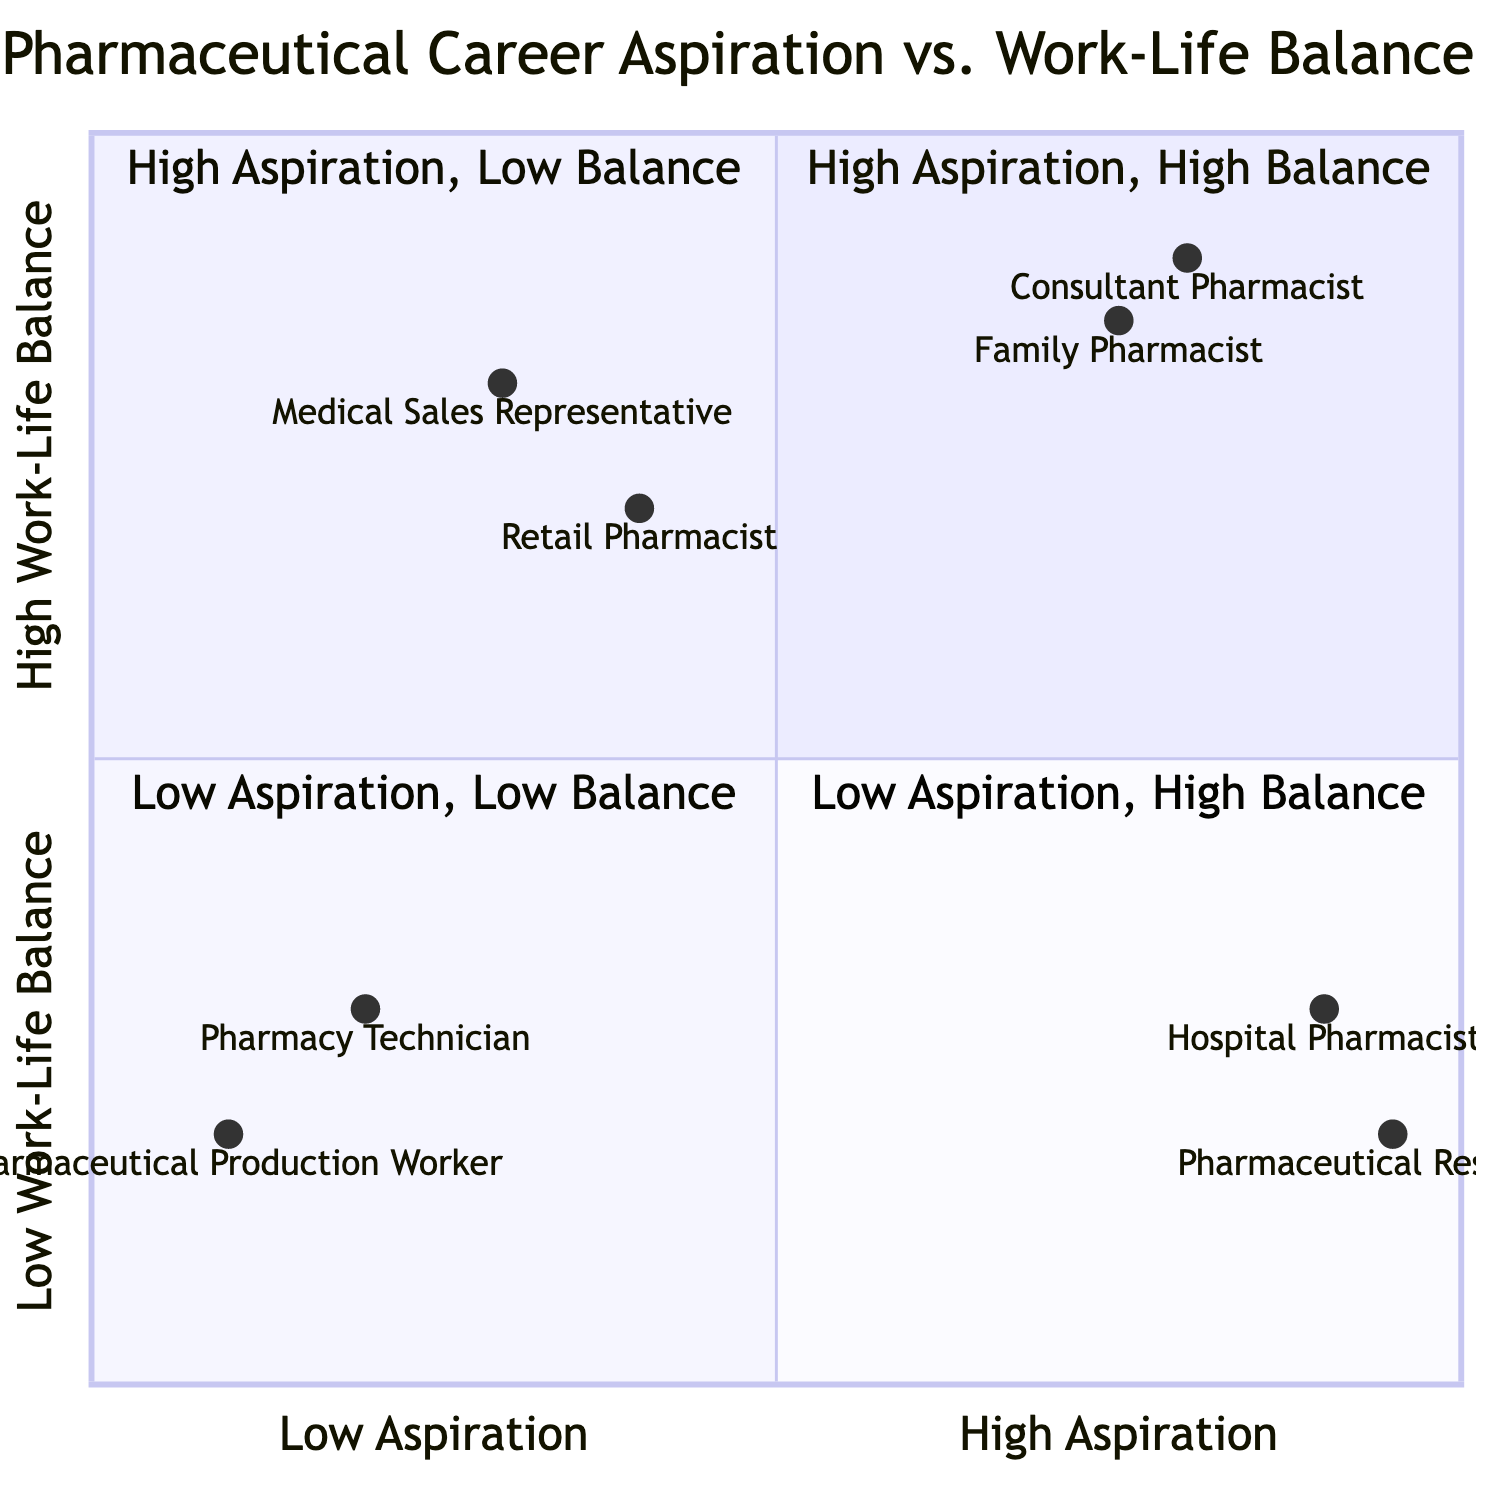What elements are in the High Aspiration, High Work-Life Balance quadrant? The diagram indicates that the elements in the High Aspiration, High Work-Life Balance quadrant are "Family Pharmacist" and "Consultant Pharmacist." These are positioned in the upper-left section of the quadrant chart, which represents high aspiration and high work-life balance.
Answer: Family Pharmacist, Consultant Pharmacist How many elements are in the Low Aspiration, Low Work-Life Balance quadrant? The Low Aspiration, Low Work-Life Balance quadrant contains two elements: "Pharmacy Technician" and "Pharmaceutical Production Worker." This can be seen as this quadrant is located in the lower-right section of the chart.
Answer: 2 Which role has the highest aspiration but the lowest work-life balance? According to the chart, the role with the highest aspiration but lowest work-life balance is "Pharmaceutical Researcher." This is evident as it is placed in the upper-right quadrant, indicating high aspiration coupled with low work-life balance.
Answer: Pharmaceutical Researcher What is the work-life balance score for the Hospital Pharmacist? The work-life balance score for "Hospital Pharmacist" is 0.3, which is noted on the y-axis of the quadrant chart where this role is positioned toward the lower end of work-life balance.
Answer: 0.3 Which element has the least aspiration in the quadrant chart? The element with the least aspiration in the quadrant chart is "Pharmaceutical Production Worker." Its position in the farthest left section of the x-axis indicates that it has low aspiration compared to other roles.
Answer: Pharmaceutical Production Worker How many roles are categorized under High Aspiration, Low Work-Life Balance? There are two roles categorized under High Aspiration, Low Work-Life Balance: "Hospital Pharmacist" and "Pharmaceutical Researcher." Both can be found in the upper-right quadrant of the chart.
Answer: 2 Which role has a better work-life balance: Retail Pharmacist or Medical Sales Representative? "Retail Pharmacist" has a better work-life balance at 0.7 compared to "Medical Sales Representative," which has a work-life balance of 0.8. However, "Medical Sales Representative" has a higher score in work-life balance, placing it higher in this aspect. The y-axis value confirms this ranking.
Answer: Medical Sales Representative What is the aspiration score for the Family Pharmacist? The aspiration score for "Family Pharmacist" is 0.75, as indicated in its position in the diagram on the x-axis, reflecting a relatively high level of aspiration compared to lower values.
Answer: 0.75 